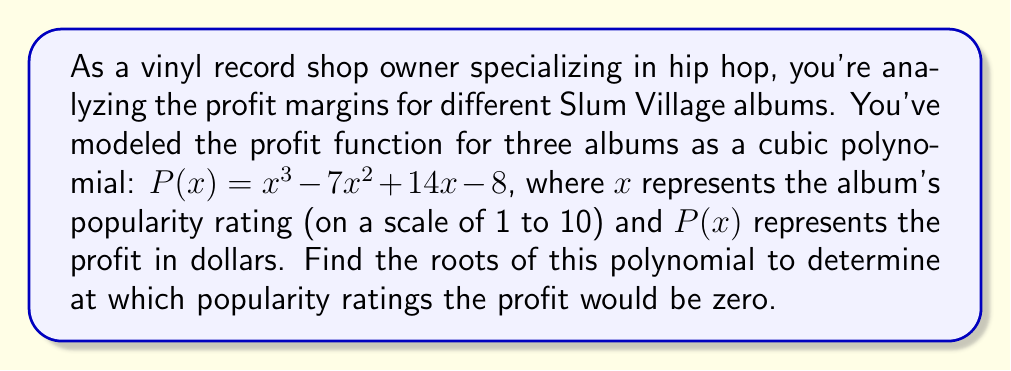Can you answer this question? To find the roots of the polynomial $P(x) = x^3 - 7x^2 + 14x - 8$, we need to factor it. Let's approach this step-by-step:

1) First, let's check if there's a rational root. We can use the rational root theorem. The possible rational roots are the factors of the constant term (8): ±1, ±2, ±4, ±8.

2) Testing these values, we find that $P(1) = 0$. So $(x-1)$ is a factor.

3) We can use polynomial long division to divide $P(x)$ by $(x-1)$:

   $x^3 - 7x^2 + 14x - 8 = (x-1)(x^2 - 6x + 8)$

4) Now we need to factor the quadratic $x^2 - 6x + 8$. We can use the quadratic formula or factor by grouping.

5) The quadratic factors as $(x-2)(x-4)$.

6) Therefore, the complete factorization is:

   $P(x) = (x-1)(x-2)(x-4)$

7) The roots of the polynomial are the values that make each factor equal to zero. So the roots are $x = 1$, $x = 2$, and $x = 4$.

These roots represent the popularity ratings at which the profit would be zero for the Slum Village albums in question.
Answer: The roots of the polynomial are $x = 1$, $x = 2$, and $x = 4$. 